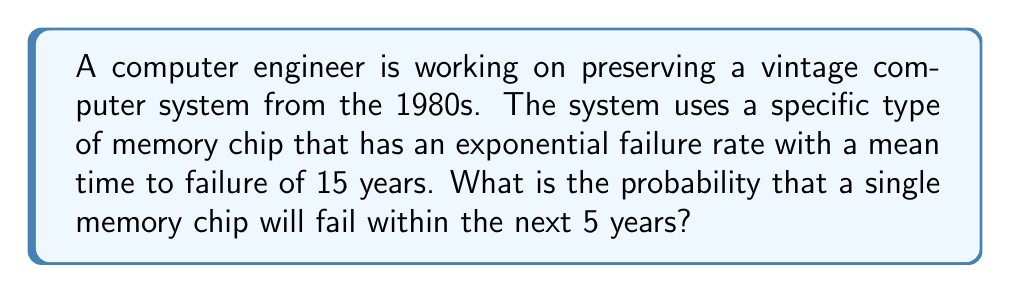Can you answer this question? To solve this problem, we'll use the exponential distribution, which is commonly used to model the lifetime of electronic components. The probability density function of the exponential distribution is:

$$f(t) = \lambda e^{-\lambda t}$$

where $\lambda$ is the failure rate.

Given:
- Mean time to failure (MTTF) = 15 years
- Time frame (t) = 5 years

Step 1: Calculate the failure rate $\lambda$
For the exponential distribution, $\lambda = \frac{1}{MTTF}$
$$\lambda = \frac{1}{15} = 0.0667 \text{ per year}$$

Step 2: Calculate the probability of failure within 5 years
The probability of failure within time t is given by the cumulative distribution function:

$$P(T \leq t) = 1 - e^{-\lambda t}$$

Substituting our values:

$$P(T \leq 5) = 1 - e^{-0.0667 \times 5}$$

Step 3: Compute the final result
$$P(T \leq 5) = 1 - e^{-0.3335}$$
$$P(T \leq 5) = 1 - 0.7164$$
$$P(T \leq 5) = 0.2836$$

Therefore, the probability that a single memory chip will fail within the next 5 years is approximately 0.2836 or 28.36%.
Answer: $0.2836$ or $28.36\%$ 